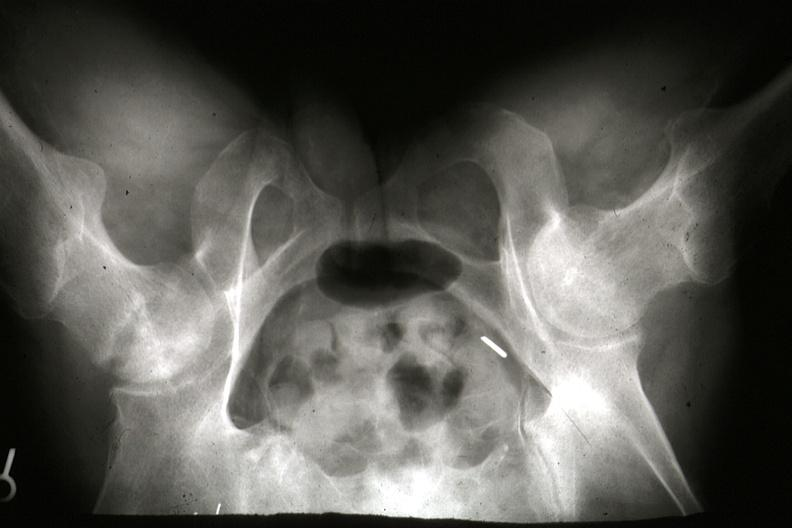when does this image show x-ray of pelvis?
Answer the question using a single word or phrase. During life showing osteonecrosis in right femoral head slides 7182 and 7183 are gross and postmortx-rays lesion 